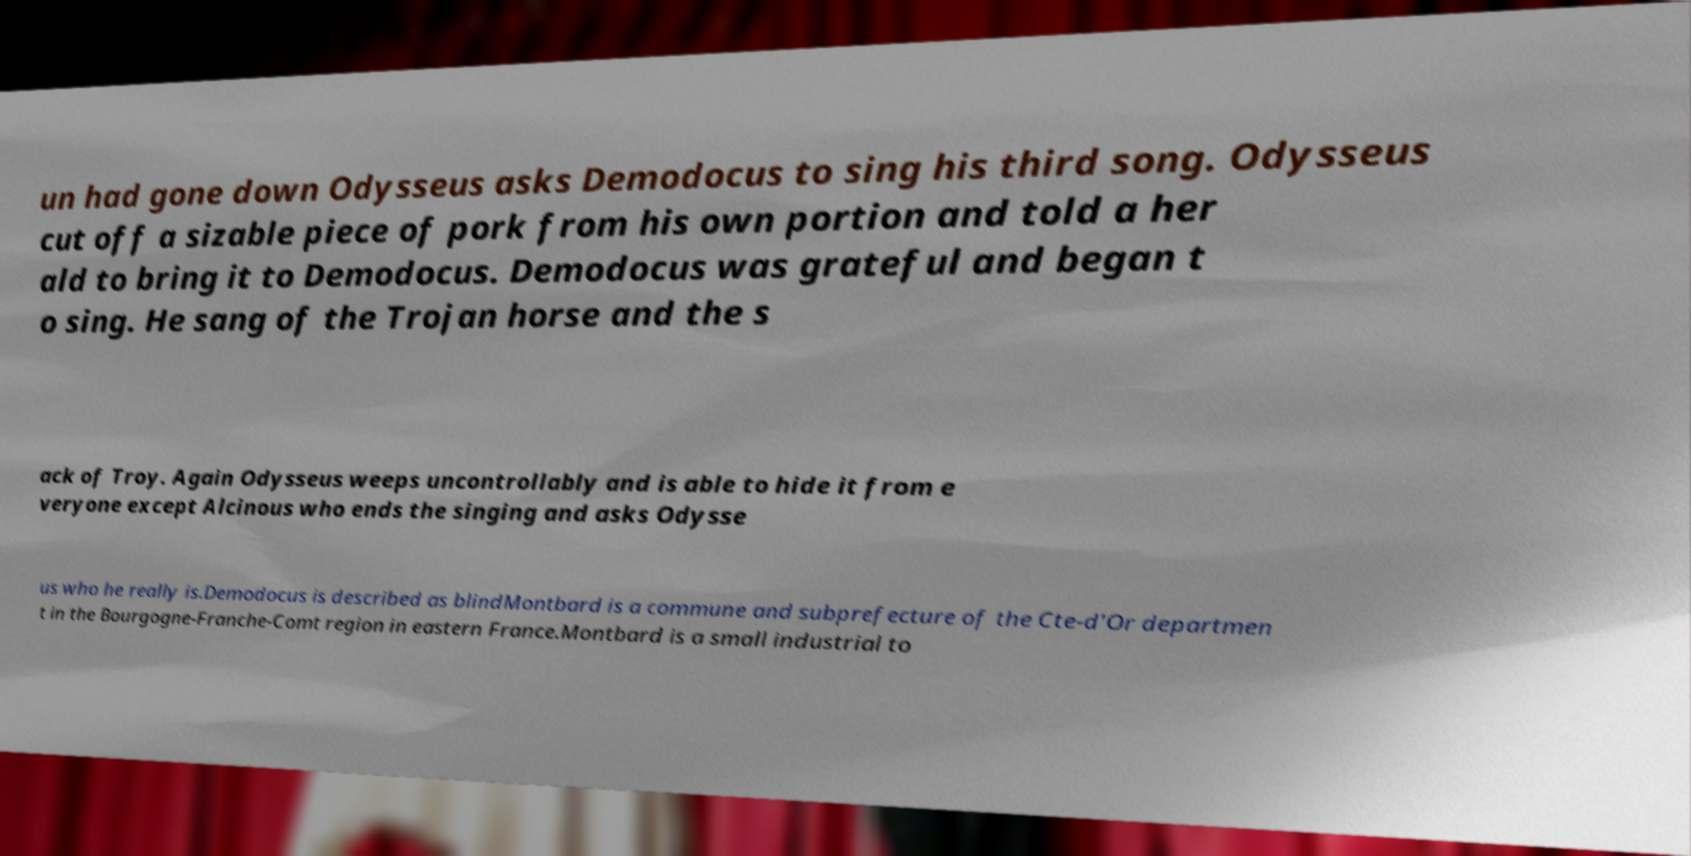Please read and relay the text visible in this image. What does it say? un had gone down Odysseus asks Demodocus to sing his third song. Odysseus cut off a sizable piece of pork from his own portion and told a her ald to bring it to Demodocus. Demodocus was grateful and began t o sing. He sang of the Trojan horse and the s ack of Troy. Again Odysseus weeps uncontrollably and is able to hide it from e veryone except Alcinous who ends the singing and asks Odysse us who he really is.Demodocus is described as blindMontbard is a commune and subprefecture of the Cte-d'Or departmen t in the Bourgogne-Franche-Comt region in eastern France.Montbard is a small industrial to 